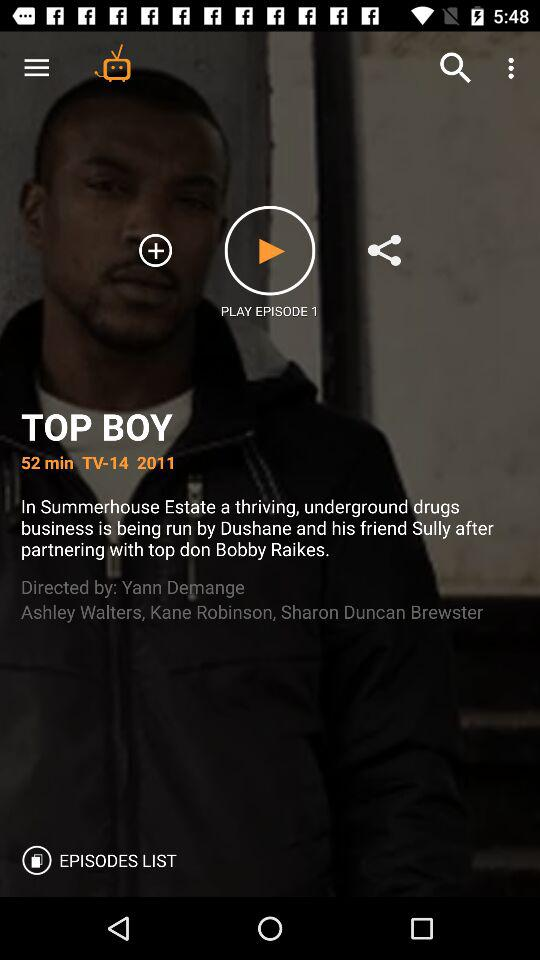How long is the episode? The episode is 52 minutes long. 